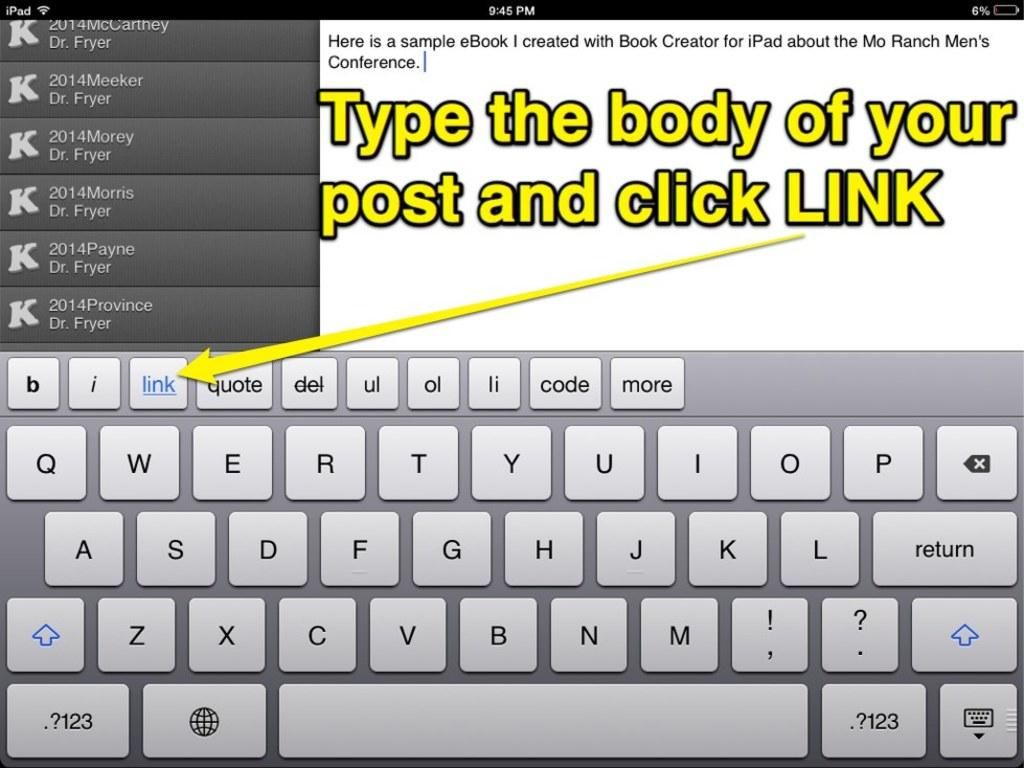<image>
Summarize the visual content of the image. A website is shown informing the user to type the body of their post and click link. 